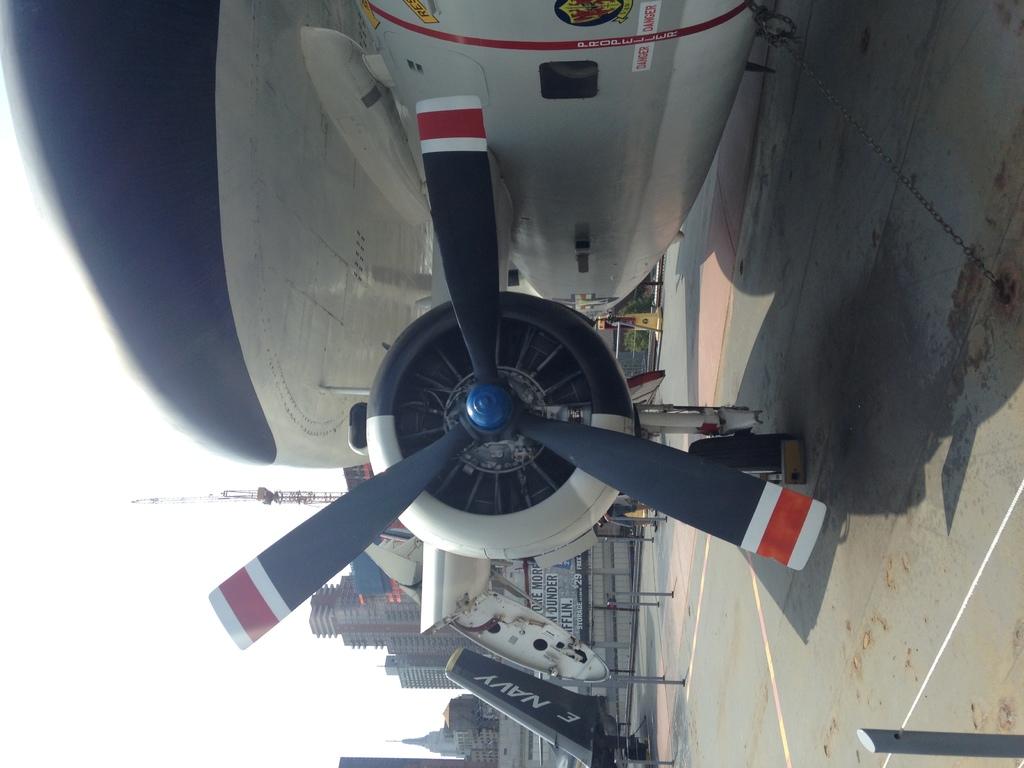What branch of the military is this?
Ensure brevity in your answer.  Navy. Is navy written beside the back of this plane?
Your answer should be very brief. Yes. 